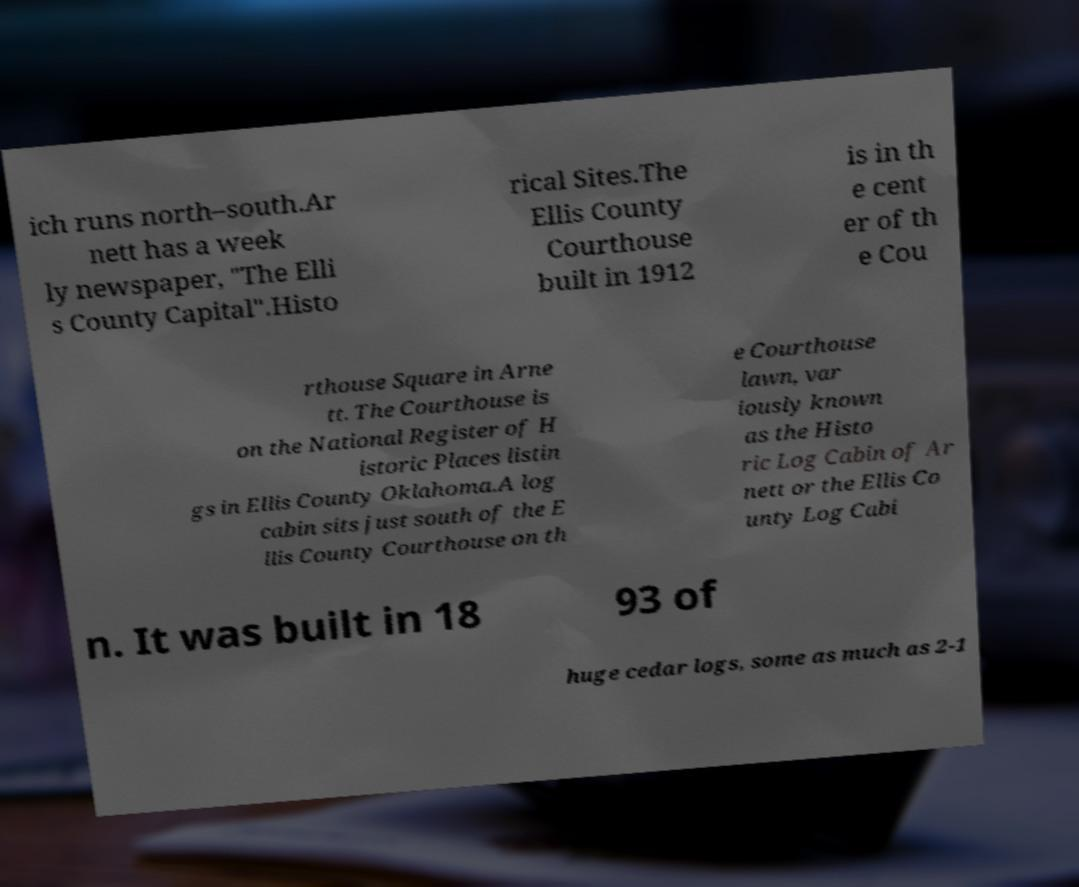For documentation purposes, I need the text within this image transcribed. Could you provide that? ich runs north–south.Ar nett has a week ly newspaper, "The Elli s County Capital".Histo rical Sites.The Ellis County Courthouse built in 1912 is in th e cent er of th e Cou rthouse Square in Arne tt. The Courthouse is on the National Register of H istoric Places listin gs in Ellis County Oklahoma.A log cabin sits just south of the E llis County Courthouse on th e Courthouse lawn, var iously known as the Histo ric Log Cabin of Ar nett or the Ellis Co unty Log Cabi n. It was built in 18 93 of huge cedar logs, some as much as 2-1 